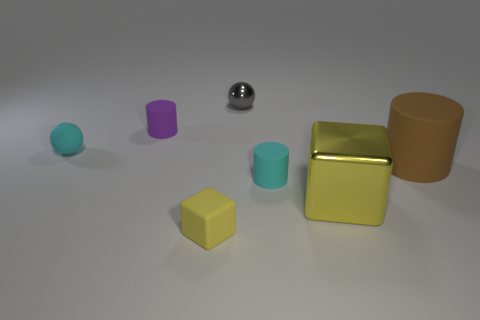Subtract all brown cubes. Subtract all blue spheres. How many cubes are left? 2 Add 1 big yellow spheres. How many objects exist? 8 Subtract all balls. How many objects are left? 5 Add 3 large yellow things. How many large yellow things exist? 4 Subtract 1 brown cylinders. How many objects are left? 6 Subtract all large yellow metal blocks. Subtract all cylinders. How many objects are left? 3 Add 1 small things. How many small things are left? 6 